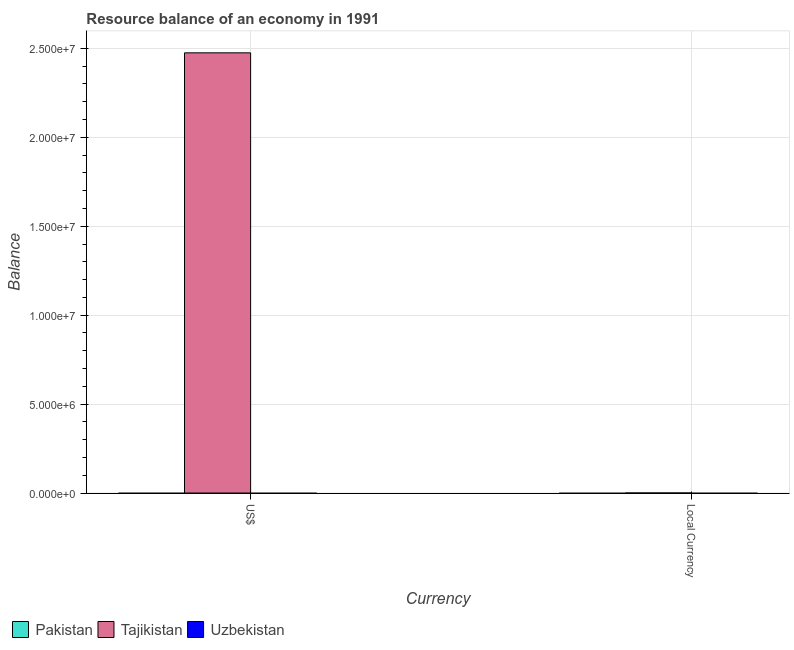Are the number of bars per tick equal to the number of legend labels?
Provide a succinct answer. No. Are the number of bars on each tick of the X-axis equal?
Give a very brief answer. Yes. How many bars are there on the 2nd tick from the left?
Provide a short and direct response. 1. How many bars are there on the 2nd tick from the right?
Provide a succinct answer. 1. What is the label of the 2nd group of bars from the left?
Your answer should be very brief. Local Currency. What is the resource balance in us$ in Tajikistan?
Provide a succinct answer. 2.47e+07. Across all countries, what is the maximum resource balance in us$?
Your response must be concise. 2.47e+07. Across all countries, what is the minimum resource balance in us$?
Provide a succinct answer. 0. In which country was the resource balance in constant us$ maximum?
Provide a succinct answer. Tajikistan. What is the total resource balance in us$ in the graph?
Provide a succinct answer. 2.47e+07. What is the difference between the resource balance in constant us$ in Uzbekistan and the resource balance in us$ in Tajikistan?
Provide a short and direct response. -2.47e+07. What is the average resource balance in us$ per country?
Your answer should be compact. 8.25e+06. What is the difference between the resource balance in us$ and resource balance in constant us$ in Tajikistan?
Offer a terse response. 2.47e+07. In how many countries, is the resource balance in constant us$ greater than 2000000 units?
Give a very brief answer. 0. In how many countries, is the resource balance in us$ greater than the average resource balance in us$ taken over all countries?
Offer a terse response. 1. How many bars are there?
Offer a terse response. 2. Are all the bars in the graph horizontal?
Your answer should be compact. No. Are the values on the major ticks of Y-axis written in scientific E-notation?
Your response must be concise. Yes. How many legend labels are there?
Offer a terse response. 3. How are the legend labels stacked?
Ensure brevity in your answer.  Horizontal. What is the title of the graph?
Your answer should be compact. Resource balance of an economy in 1991. Does "Togo" appear as one of the legend labels in the graph?
Provide a succinct answer. No. What is the label or title of the X-axis?
Provide a short and direct response. Currency. What is the label or title of the Y-axis?
Give a very brief answer. Balance. What is the Balance in Pakistan in US$?
Ensure brevity in your answer.  0. What is the Balance of Tajikistan in US$?
Your answer should be compact. 2.47e+07. What is the Balance in Uzbekistan in US$?
Provide a succinct answer. 0. What is the Balance in Tajikistan in Local Currency?
Keep it short and to the point. 1320. Across all Currency, what is the maximum Balance of Tajikistan?
Provide a short and direct response. 2.47e+07. Across all Currency, what is the minimum Balance of Tajikistan?
Keep it short and to the point. 1320. What is the total Balance of Pakistan in the graph?
Your answer should be very brief. 0. What is the total Balance of Tajikistan in the graph?
Ensure brevity in your answer.  2.47e+07. What is the difference between the Balance of Tajikistan in US$ and that in Local Currency?
Make the answer very short. 2.47e+07. What is the average Balance in Pakistan per Currency?
Your answer should be compact. 0. What is the average Balance in Tajikistan per Currency?
Make the answer very short. 1.24e+07. What is the average Balance of Uzbekistan per Currency?
Make the answer very short. 0. What is the ratio of the Balance of Tajikistan in US$ to that in Local Currency?
Offer a terse response. 1.87e+04. What is the difference between the highest and the second highest Balance of Tajikistan?
Provide a succinct answer. 2.47e+07. What is the difference between the highest and the lowest Balance in Tajikistan?
Ensure brevity in your answer.  2.47e+07. 